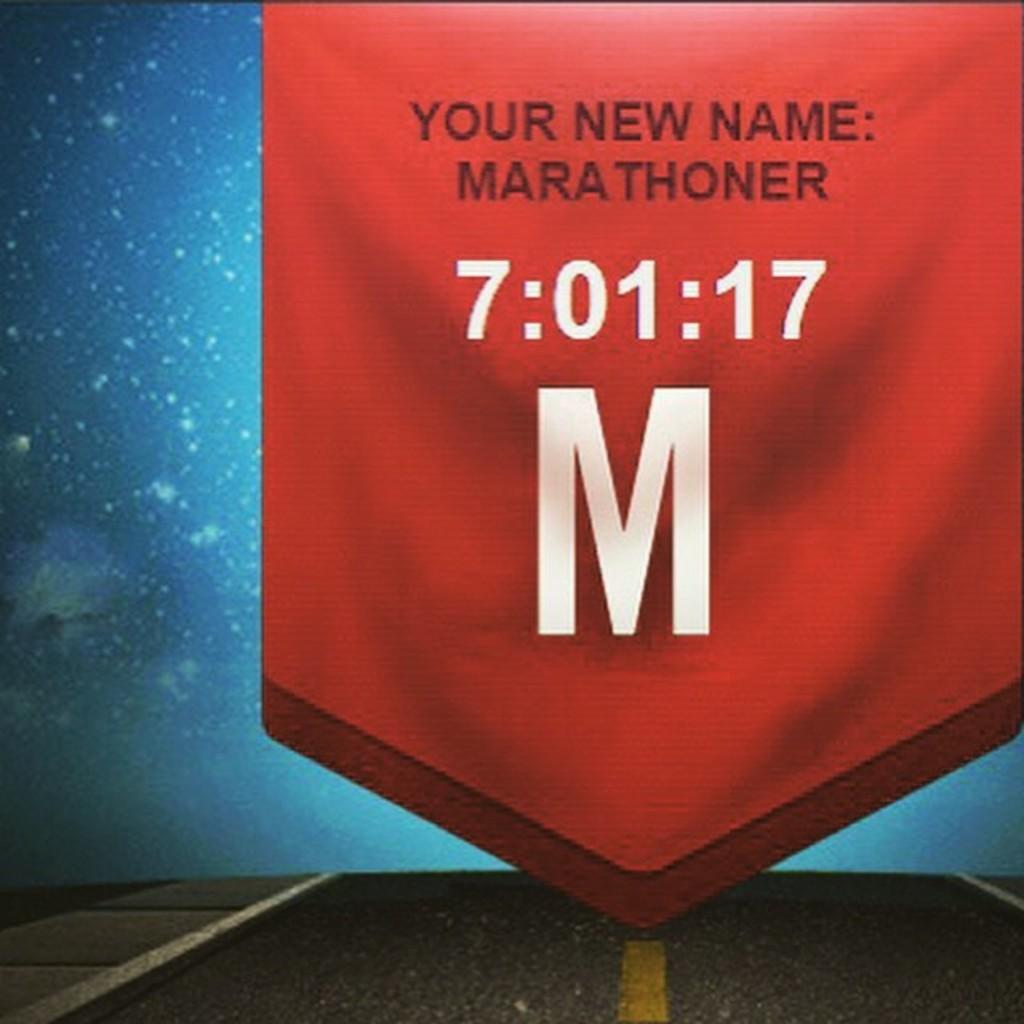Could you give a brief overview of what you see in this image? In the center of the image, we can see a flag and at the bottom, there is road and the background is in blue color. 